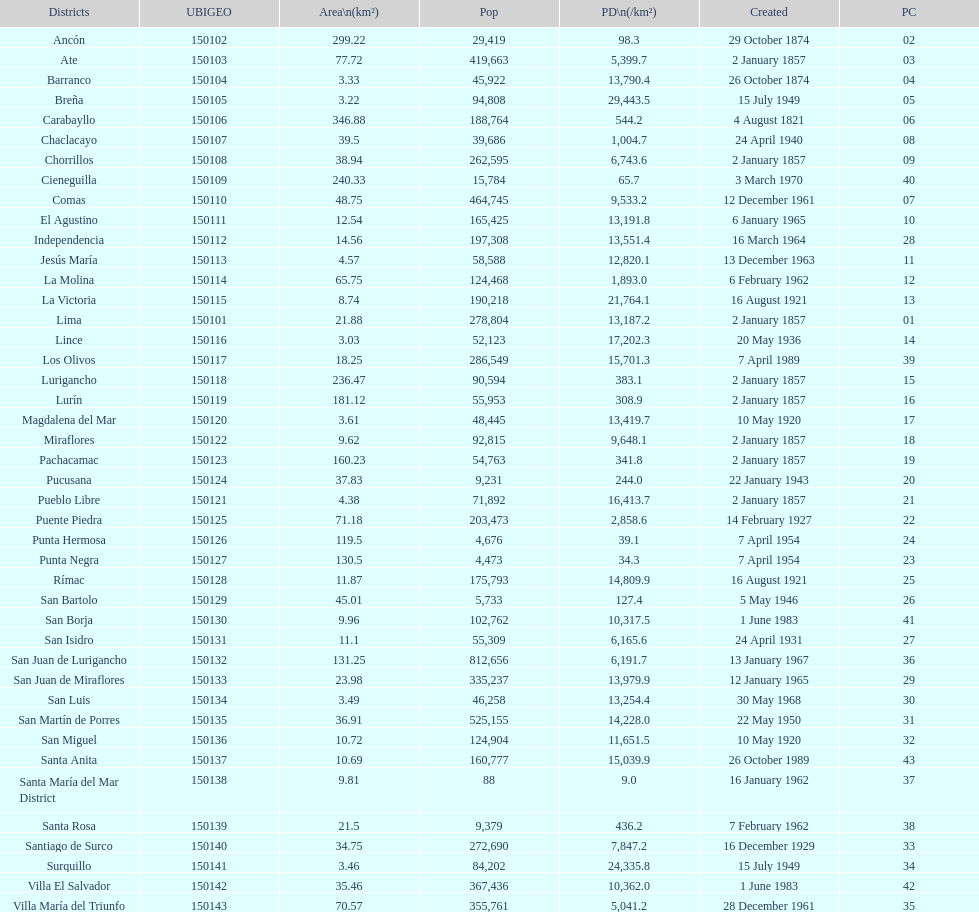What is the overall count of lima's districts? 43. 